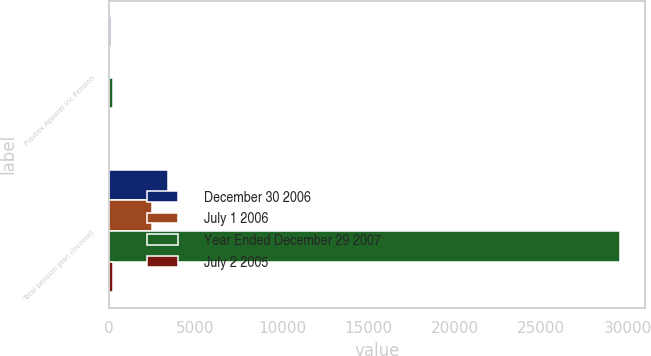<chart> <loc_0><loc_0><loc_500><loc_500><stacked_bar_chart><ecel><fcel>Playtex Apparel Inc Pension<fcel>Total pension plan (income)<nl><fcel>December 30 2006<fcel>127<fcel>3390<nl><fcel>July 1 2006<fcel>30<fcel>2452<nl><fcel>Year Ended December 29 2007<fcel>234<fcel>29542<nl><fcel>July 2 2005<fcel>9<fcel>234<nl></chart> 